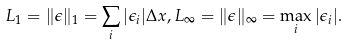Convert formula to latex. <formula><loc_0><loc_0><loc_500><loc_500>L _ { 1 } = \| \epsilon \| _ { 1 } = \sum _ { i } | \epsilon _ { i } | \Delta x , L _ { \infty } = \| \epsilon \| _ { \infty } = \max _ { i } | \epsilon _ { i } | .</formula> 